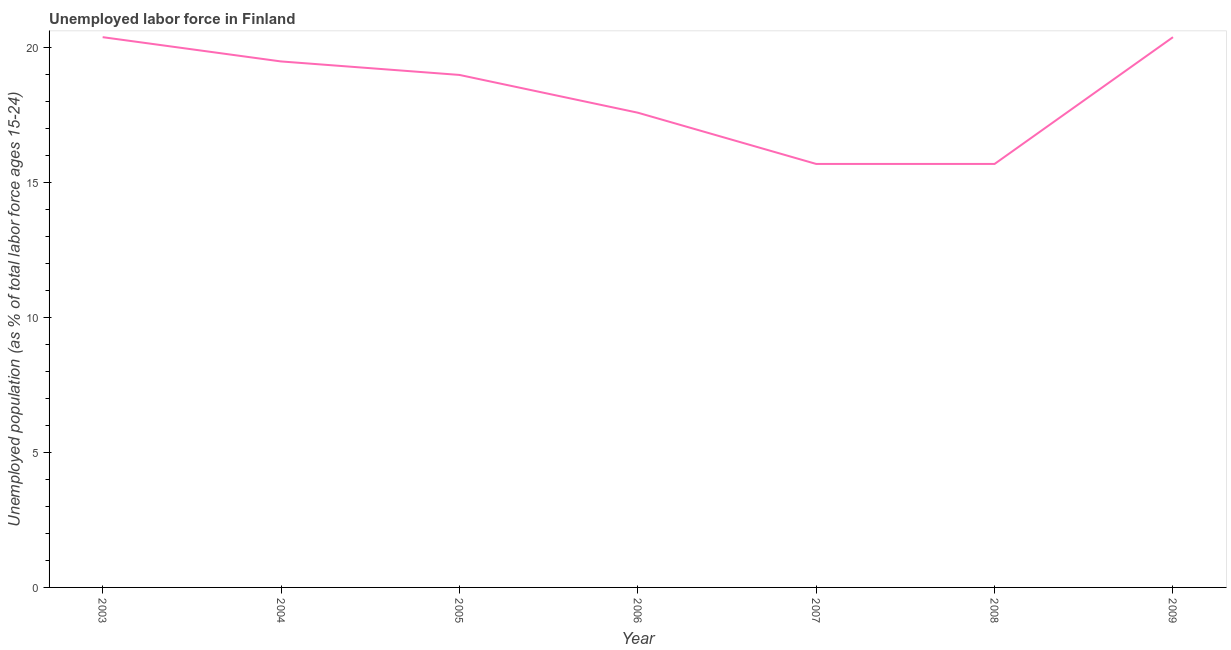Across all years, what is the maximum total unemployed youth population?
Keep it short and to the point. 20.4. Across all years, what is the minimum total unemployed youth population?
Ensure brevity in your answer.  15.7. In which year was the total unemployed youth population minimum?
Offer a terse response. 2007. What is the sum of the total unemployed youth population?
Your response must be concise. 128.3. What is the difference between the total unemployed youth population in 2003 and 2004?
Make the answer very short. 0.9. What is the average total unemployed youth population per year?
Provide a short and direct response. 18.33. What is the ratio of the total unemployed youth population in 2008 to that in 2009?
Offer a terse response. 0.77. What is the difference between the highest and the second highest total unemployed youth population?
Ensure brevity in your answer.  0. Is the sum of the total unemployed youth population in 2005 and 2007 greater than the maximum total unemployed youth population across all years?
Your response must be concise. Yes. What is the difference between the highest and the lowest total unemployed youth population?
Give a very brief answer. 4.7. In how many years, is the total unemployed youth population greater than the average total unemployed youth population taken over all years?
Give a very brief answer. 4. Are the values on the major ticks of Y-axis written in scientific E-notation?
Offer a terse response. No. What is the title of the graph?
Your answer should be compact. Unemployed labor force in Finland. What is the label or title of the Y-axis?
Offer a terse response. Unemployed population (as % of total labor force ages 15-24). What is the Unemployed population (as % of total labor force ages 15-24) in 2003?
Your answer should be compact. 20.4. What is the Unemployed population (as % of total labor force ages 15-24) of 2004?
Provide a succinct answer. 19.5. What is the Unemployed population (as % of total labor force ages 15-24) in 2005?
Your response must be concise. 19. What is the Unemployed population (as % of total labor force ages 15-24) in 2006?
Give a very brief answer. 17.6. What is the Unemployed population (as % of total labor force ages 15-24) of 2007?
Your answer should be very brief. 15.7. What is the Unemployed population (as % of total labor force ages 15-24) of 2008?
Keep it short and to the point. 15.7. What is the Unemployed population (as % of total labor force ages 15-24) in 2009?
Offer a terse response. 20.4. What is the difference between the Unemployed population (as % of total labor force ages 15-24) in 2003 and 2004?
Provide a succinct answer. 0.9. What is the difference between the Unemployed population (as % of total labor force ages 15-24) in 2003 and 2005?
Give a very brief answer. 1.4. What is the difference between the Unemployed population (as % of total labor force ages 15-24) in 2003 and 2007?
Make the answer very short. 4.7. What is the difference between the Unemployed population (as % of total labor force ages 15-24) in 2003 and 2008?
Provide a short and direct response. 4.7. What is the difference between the Unemployed population (as % of total labor force ages 15-24) in 2003 and 2009?
Make the answer very short. 0. What is the difference between the Unemployed population (as % of total labor force ages 15-24) in 2004 and 2005?
Offer a very short reply. 0.5. What is the difference between the Unemployed population (as % of total labor force ages 15-24) in 2005 and 2006?
Keep it short and to the point. 1.4. What is the difference between the Unemployed population (as % of total labor force ages 15-24) in 2005 and 2007?
Give a very brief answer. 3.3. What is the difference between the Unemployed population (as % of total labor force ages 15-24) in 2006 and 2007?
Make the answer very short. 1.9. What is the difference between the Unemployed population (as % of total labor force ages 15-24) in 2006 and 2008?
Keep it short and to the point. 1.9. What is the difference between the Unemployed population (as % of total labor force ages 15-24) in 2008 and 2009?
Your response must be concise. -4.7. What is the ratio of the Unemployed population (as % of total labor force ages 15-24) in 2003 to that in 2004?
Ensure brevity in your answer.  1.05. What is the ratio of the Unemployed population (as % of total labor force ages 15-24) in 2003 to that in 2005?
Your answer should be compact. 1.07. What is the ratio of the Unemployed population (as % of total labor force ages 15-24) in 2003 to that in 2006?
Offer a very short reply. 1.16. What is the ratio of the Unemployed population (as % of total labor force ages 15-24) in 2003 to that in 2007?
Your response must be concise. 1.3. What is the ratio of the Unemployed population (as % of total labor force ages 15-24) in 2003 to that in 2008?
Give a very brief answer. 1.3. What is the ratio of the Unemployed population (as % of total labor force ages 15-24) in 2003 to that in 2009?
Provide a succinct answer. 1. What is the ratio of the Unemployed population (as % of total labor force ages 15-24) in 2004 to that in 2006?
Offer a terse response. 1.11. What is the ratio of the Unemployed population (as % of total labor force ages 15-24) in 2004 to that in 2007?
Provide a short and direct response. 1.24. What is the ratio of the Unemployed population (as % of total labor force ages 15-24) in 2004 to that in 2008?
Offer a terse response. 1.24. What is the ratio of the Unemployed population (as % of total labor force ages 15-24) in 2004 to that in 2009?
Offer a terse response. 0.96. What is the ratio of the Unemployed population (as % of total labor force ages 15-24) in 2005 to that in 2006?
Your answer should be compact. 1.08. What is the ratio of the Unemployed population (as % of total labor force ages 15-24) in 2005 to that in 2007?
Provide a succinct answer. 1.21. What is the ratio of the Unemployed population (as % of total labor force ages 15-24) in 2005 to that in 2008?
Offer a very short reply. 1.21. What is the ratio of the Unemployed population (as % of total labor force ages 15-24) in 2005 to that in 2009?
Your answer should be very brief. 0.93. What is the ratio of the Unemployed population (as % of total labor force ages 15-24) in 2006 to that in 2007?
Ensure brevity in your answer.  1.12. What is the ratio of the Unemployed population (as % of total labor force ages 15-24) in 2006 to that in 2008?
Offer a very short reply. 1.12. What is the ratio of the Unemployed population (as % of total labor force ages 15-24) in 2006 to that in 2009?
Offer a terse response. 0.86. What is the ratio of the Unemployed population (as % of total labor force ages 15-24) in 2007 to that in 2009?
Provide a short and direct response. 0.77. What is the ratio of the Unemployed population (as % of total labor force ages 15-24) in 2008 to that in 2009?
Make the answer very short. 0.77. 